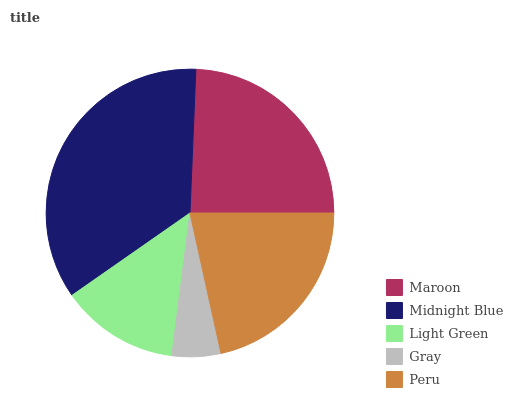Is Gray the minimum?
Answer yes or no. Yes. Is Midnight Blue the maximum?
Answer yes or no. Yes. Is Light Green the minimum?
Answer yes or no. No. Is Light Green the maximum?
Answer yes or no. No. Is Midnight Blue greater than Light Green?
Answer yes or no. Yes. Is Light Green less than Midnight Blue?
Answer yes or no. Yes. Is Light Green greater than Midnight Blue?
Answer yes or no. No. Is Midnight Blue less than Light Green?
Answer yes or no. No. Is Peru the high median?
Answer yes or no. Yes. Is Peru the low median?
Answer yes or no. Yes. Is Light Green the high median?
Answer yes or no. No. Is Maroon the low median?
Answer yes or no. No. 